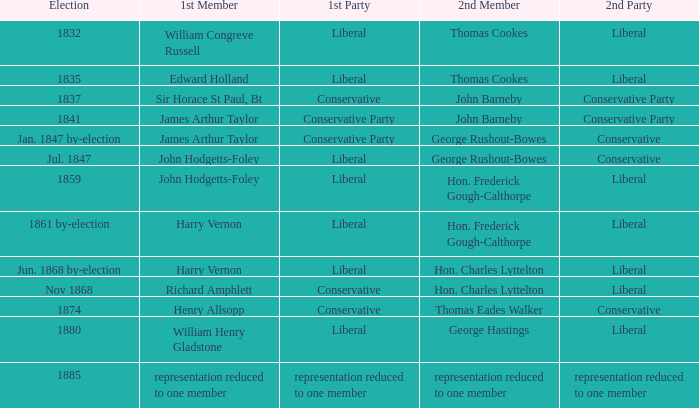What was the following party, when the preceding member was john hodgetts-foley, and the next member was hon. frederick gough-calthorpe? Liberal. 